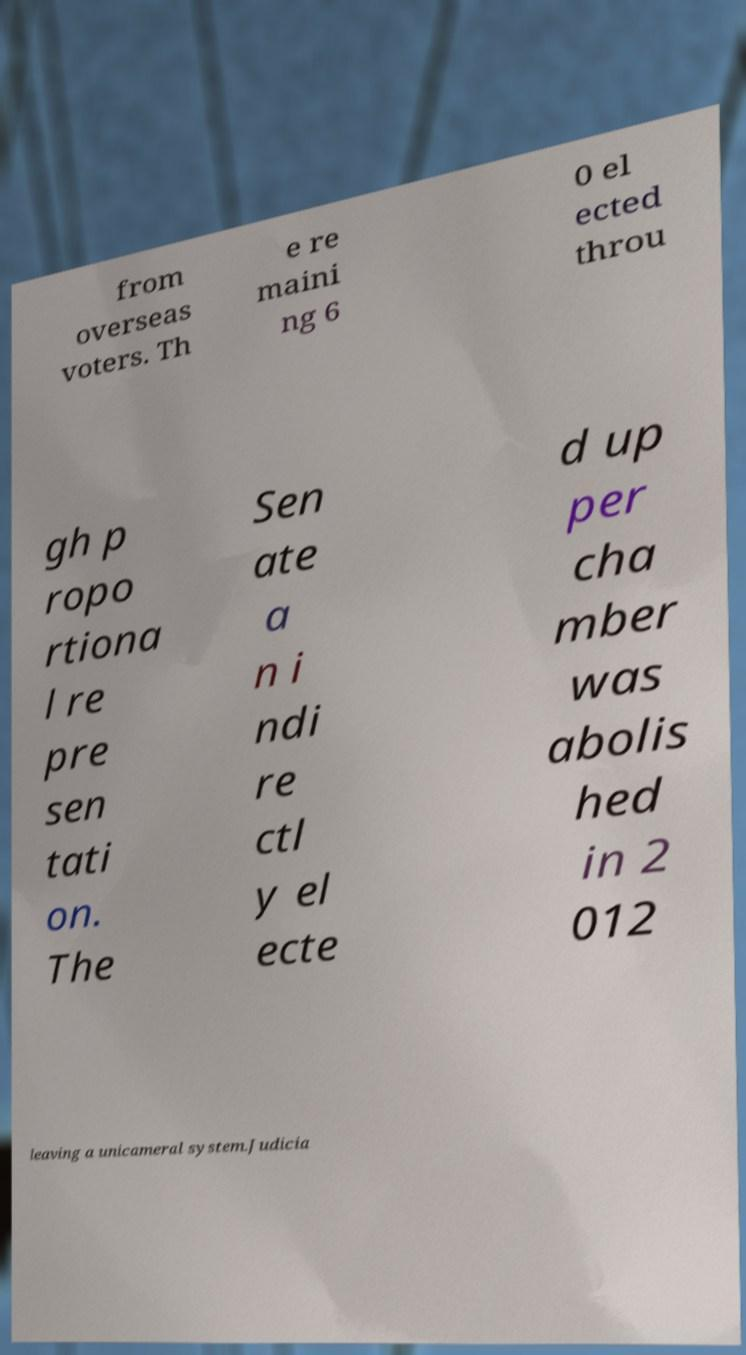Could you extract and type out the text from this image? from overseas voters. Th e re maini ng 6 0 el ected throu gh p ropo rtiona l re pre sen tati on. The Sen ate a n i ndi re ctl y el ecte d up per cha mber was abolis hed in 2 012 leaving a unicameral system.Judicia 